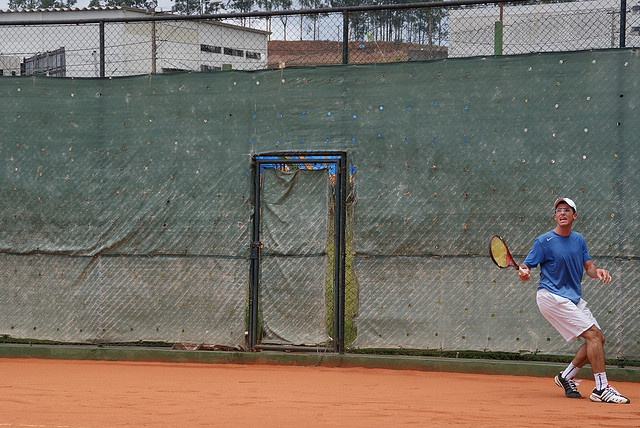Describe the objects in this image and their specific colors. I can see people in lightgray, navy, blue, darkgray, and lavender tones and tennis racket in lightgray, tan, maroon, gray, and black tones in this image. 